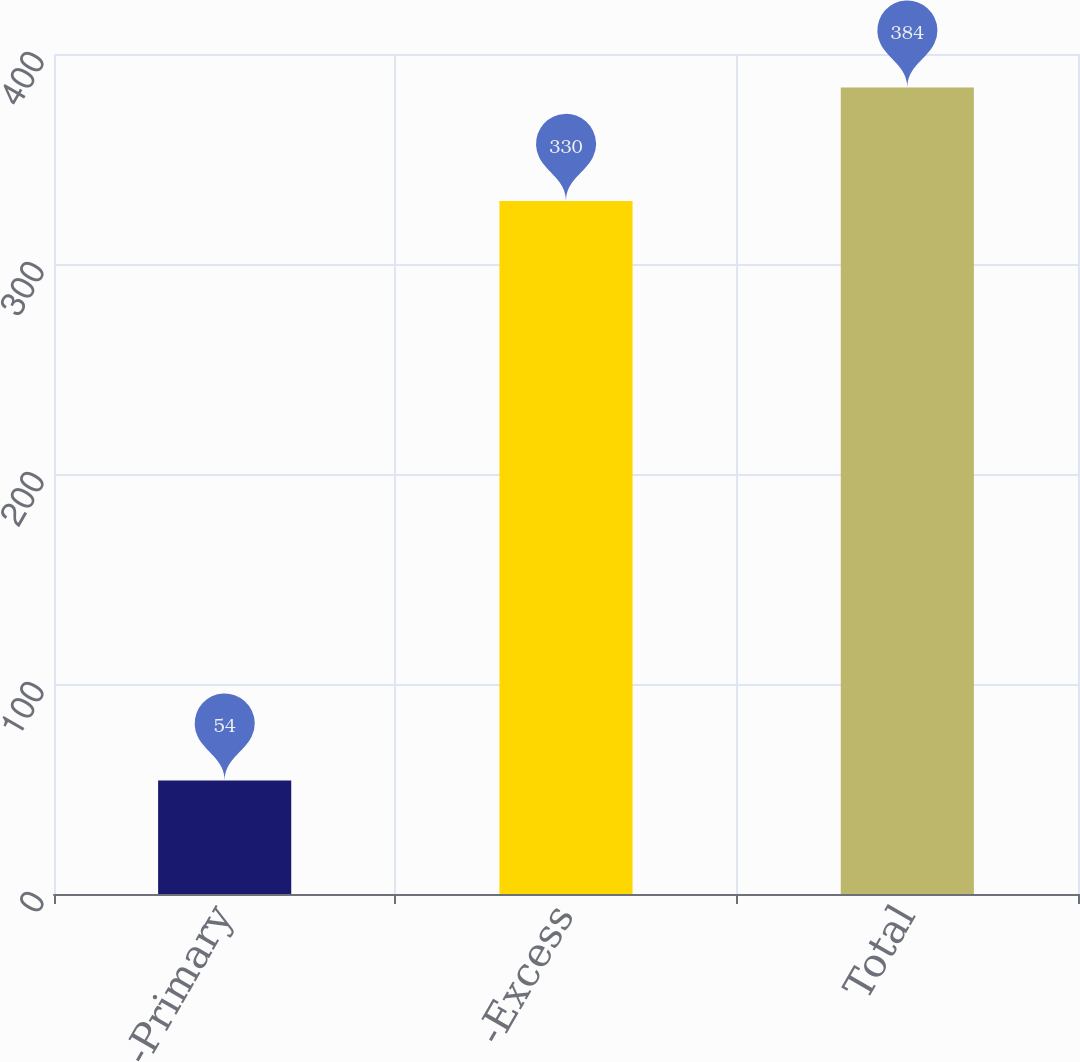Convert chart to OTSL. <chart><loc_0><loc_0><loc_500><loc_500><bar_chart><fcel>-Primary<fcel>-Excess<fcel>Total<nl><fcel>54<fcel>330<fcel>384<nl></chart> 